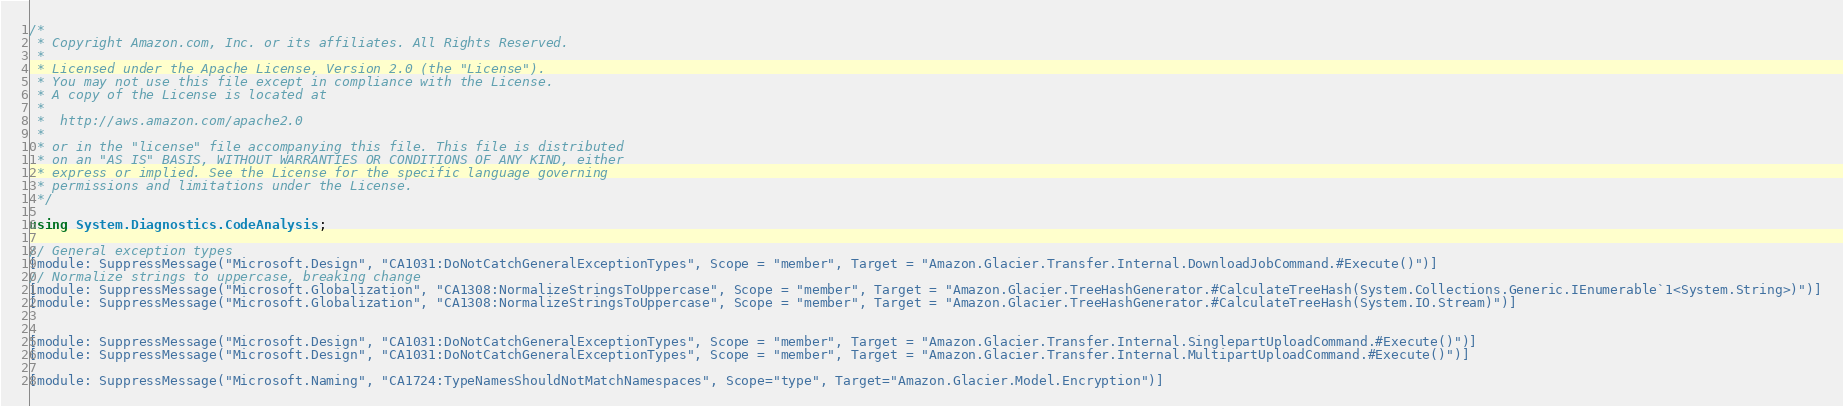Convert code to text. <code><loc_0><loc_0><loc_500><loc_500><_C#_>/*
 * Copyright Amazon.com, Inc. or its affiliates. All Rights Reserved.
 * 
 * Licensed under the Apache License, Version 2.0 (the "License").
 * You may not use this file except in compliance with the License.
 * A copy of the License is located at
 * 
 *  http://aws.amazon.com/apache2.0
 * 
 * or in the "license" file accompanying this file. This file is distributed
 * on an "AS IS" BASIS, WITHOUT WARRANTIES OR CONDITIONS OF ANY KIND, either
 * express or implied. See the License for the specific language governing
 * permissions and limitations under the License.
 */

using System.Diagnostics.CodeAnalysis;

// General exception types
[module: SuppressMessage("Microsoft.Design", "CA1031:DoNotCatchGeneralExceptionTypes", Scope = "member", Target = "Amazon.Glacier.Transfer.Internal.DownloadJobCommand.#Execute()")]
// Normalize strings to uppercase, breaking change
[module: SuppressMessage("Microsoft.Globalization", "CA1308:NormalizeStringsToUppercase", Scope = "member", Target = "Amazon.Glacier.TreeHashGenerator.#CalculateTreeHash(System.Collections.Generic.IEnumerable`1<System.String>)")]
[module: SuppressMessage("Microsoft.Globalization", "CA1308:NormalizeStringsToUppercase", Scope = "member", Target = "Amazon.Glacier.TreeHashGenerator.#CalculateTreeHash(System.IO.Stream)")]


[module: SuppressMessage("Microsoft.Design", "CA1031:DoNotCatchGeneralExceptionTypes", Scope = "member", Target = "Amazon.Glacier.Transfer.Internal.SinglepartUploadCommand.#Execute()")]
[module: SuppressMessage("Microsoft.Design", "CA1031:DoNotCatchGeneralExceptionTypes", Scope = "member", Target = "Amazon.Glacier.Transfer.Internal.MultipartUploadCommand.#Execute()")]

[module: SuppressMessage("Microsoft.Naming", "CA1724:TypeNamesShouldNotMatchNamespaces", Scope="type", Target="Amazon.Glacier.Model.Encryption")]</code> 